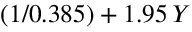<formula> <loc_0><loc_0><loc_500><loc_500>( 1 / 0 . 3 8 5 ) + 1 . 9 5 \, Y</formula> 